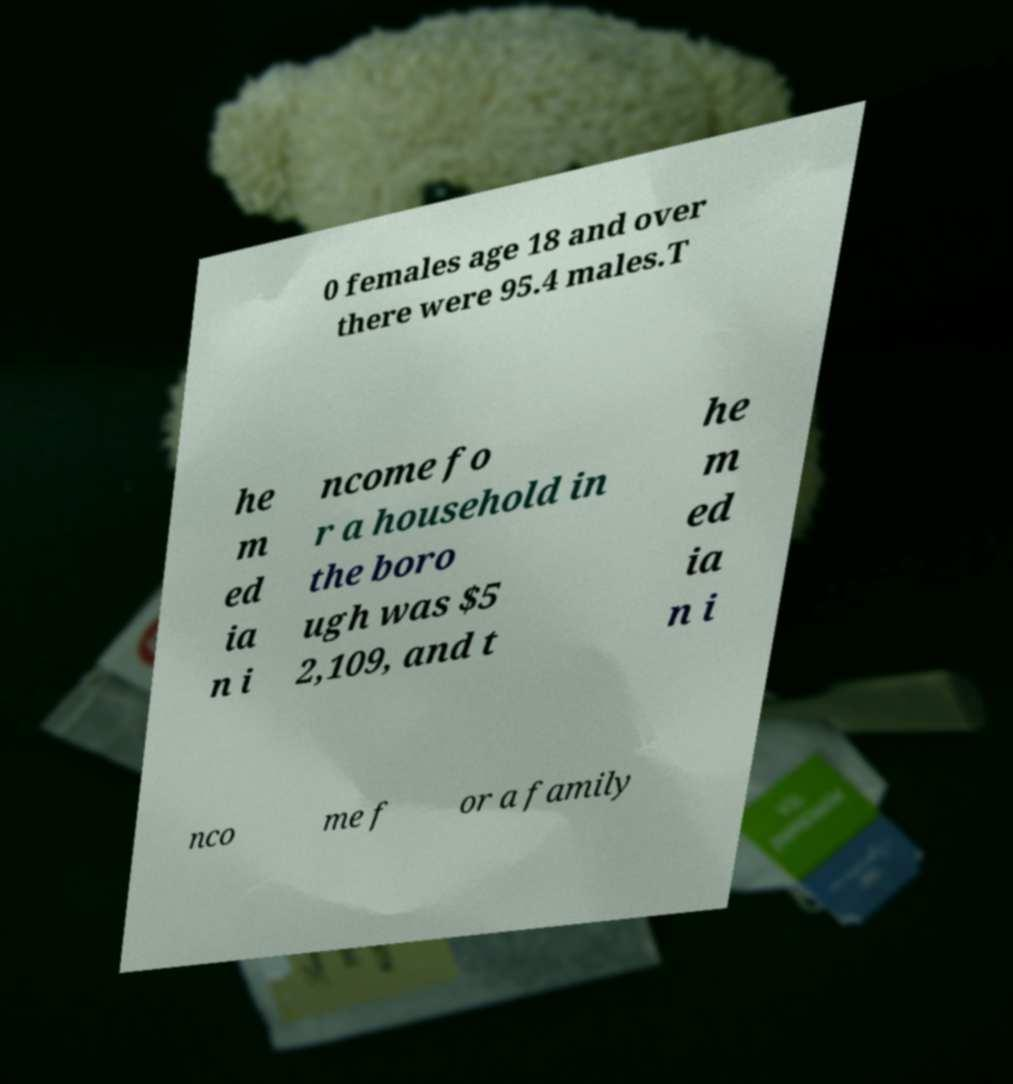Can you read and provide the text displayed in the image?This photo seems to have some interesting text. Can you extract and type it out for me? 0 females age 18 and over there were 95.4 males.T he m ed ia n i ncome fo r a household in the boro ugh was $5 2,109, and t he m ed ia n i nco me f or a family 